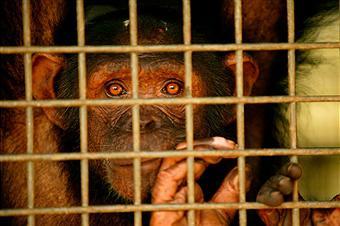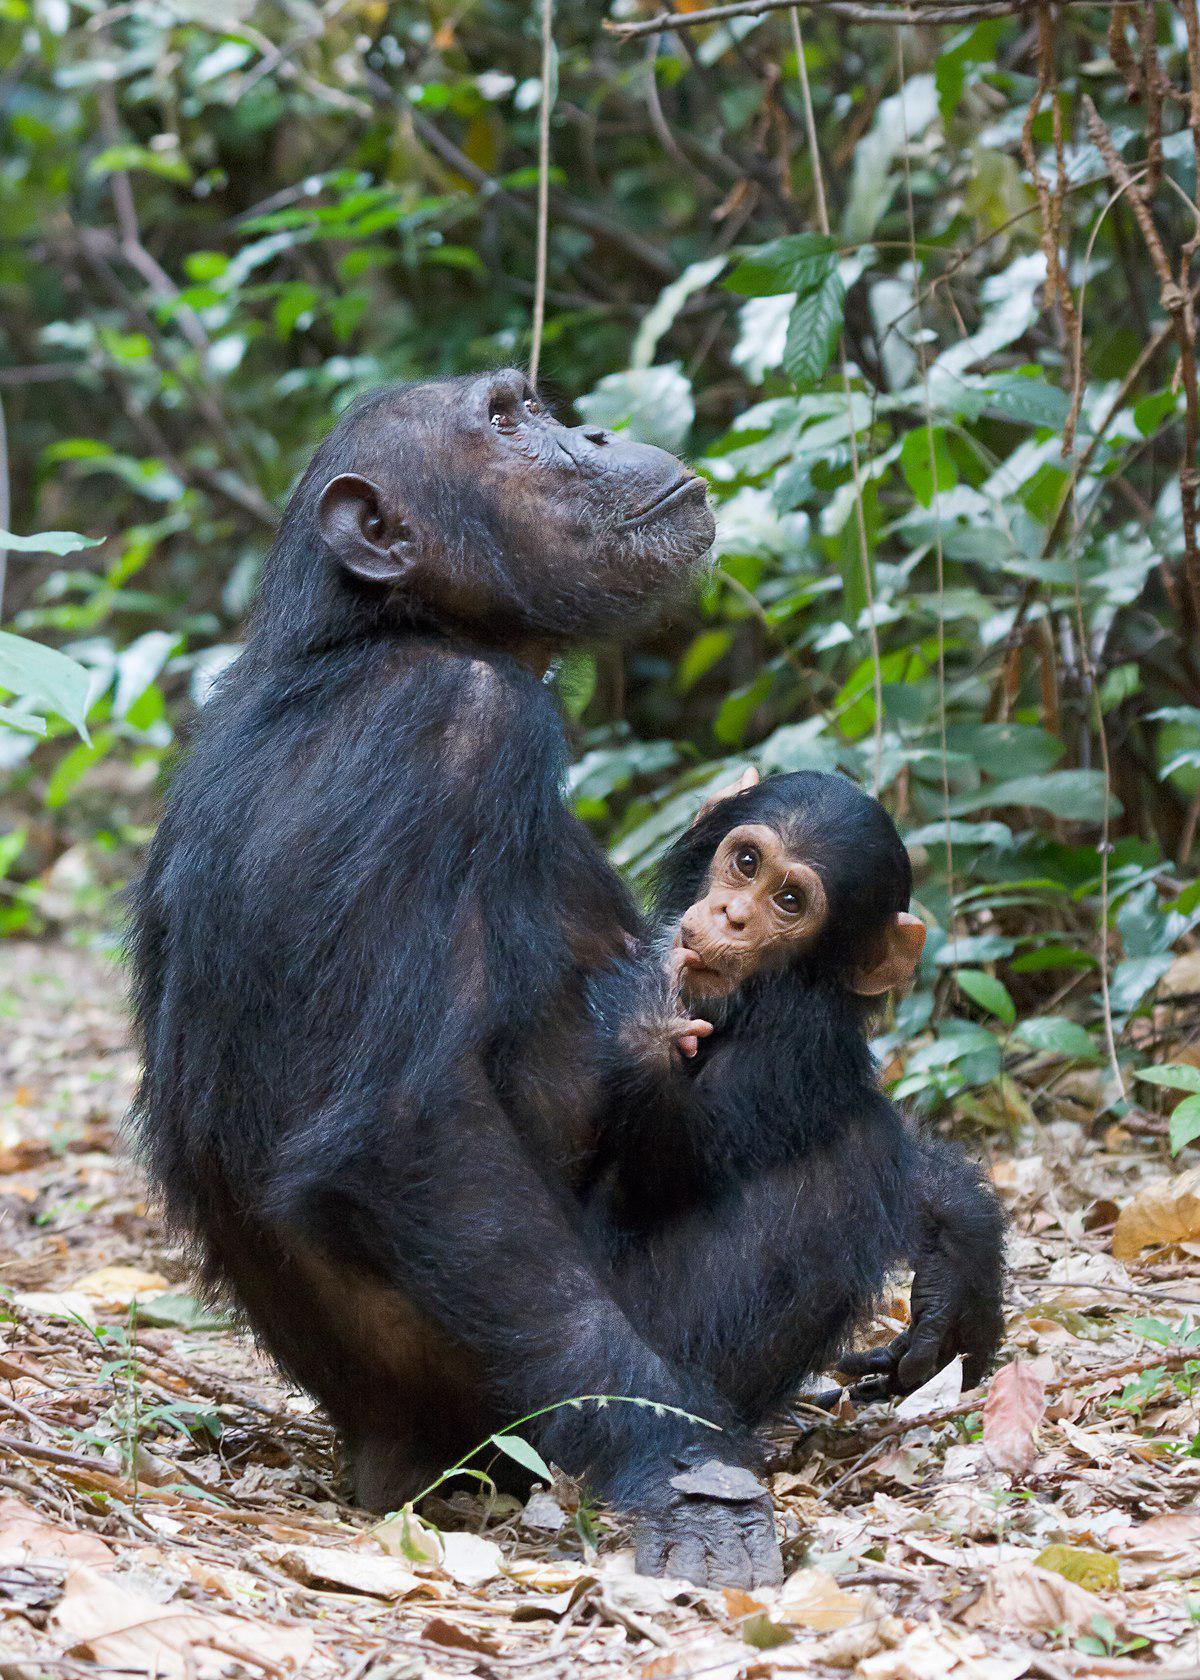The first image is the image on the left, the second image is the image on the right. For the images shown, is this caption "An image shows exactly one chimp, in a squatting position with forearms on knees." true? Answer yes or no. No. 